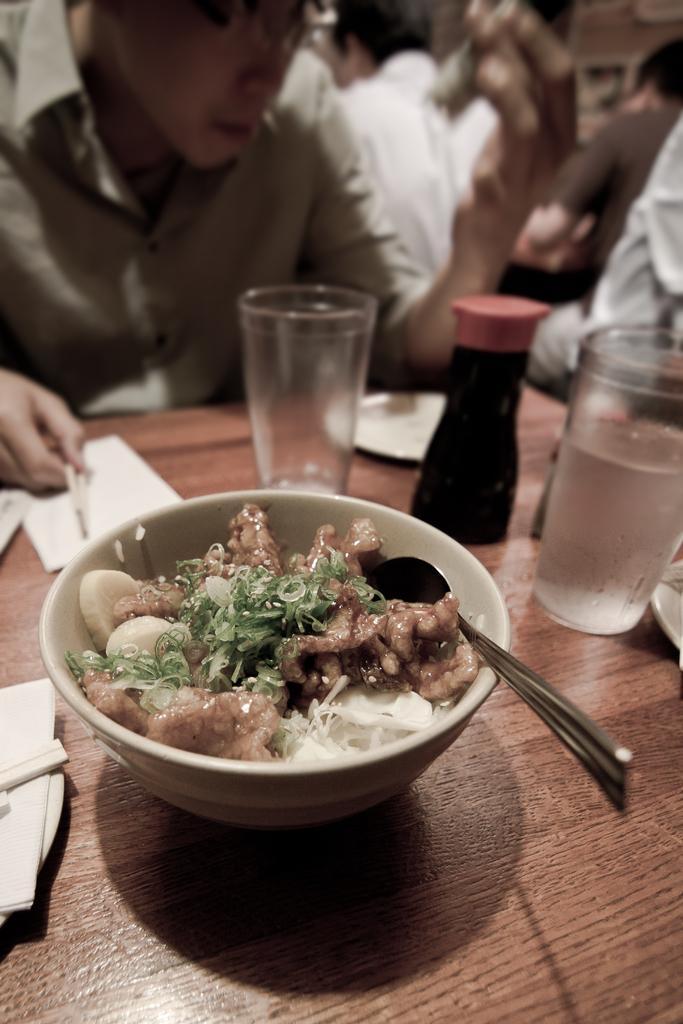Describe this image in one or two sentences. In this image, we can see persons wearing clothes. There is a table in the middle of the image contains glasses, papers, bottle and bowl with some food. 